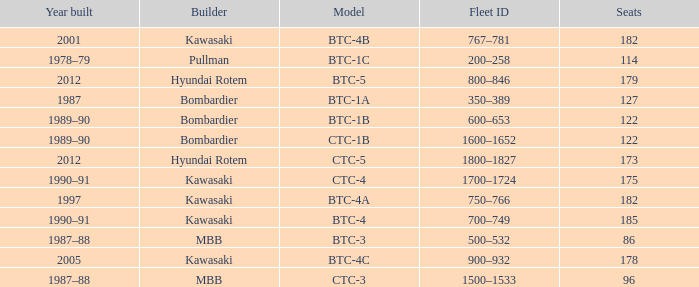How many seats does the BTC-5 model have? 179.0. 